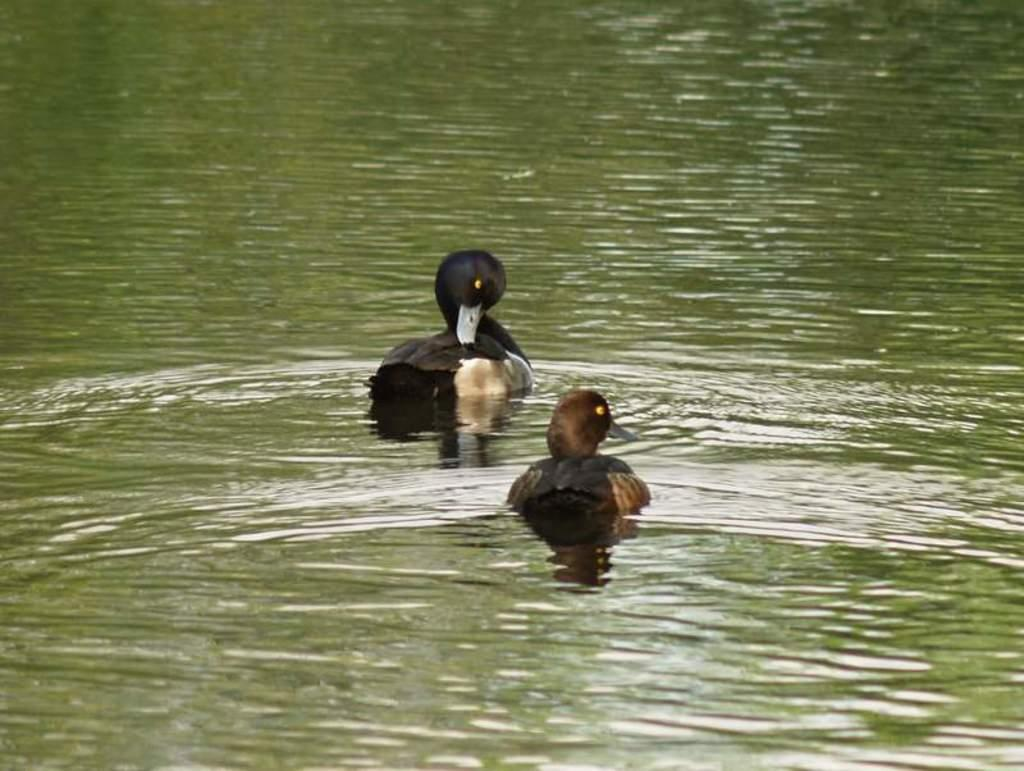What animals are present in the image? There are two ducks in the image. Where are the ducks located? The ducks are on the water. What famous actor can be seen joining the ducks in the image? There is no actor present in the image; it only features two ducks on the water. 